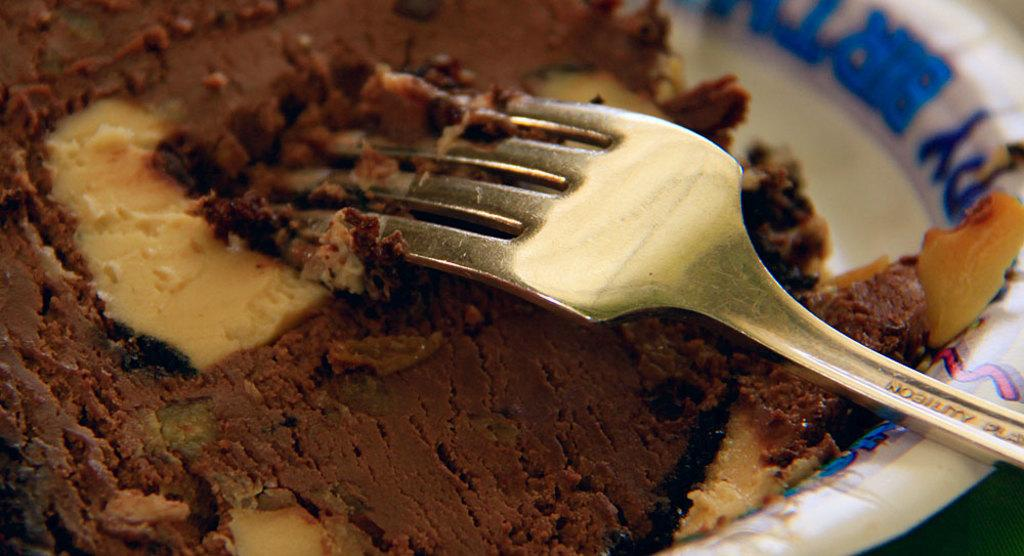What utensil is visible in the image? There is a fork in the image. What is the fork used for in the image? The fork is likely used for eating the food in the plate. What is on the plate in the image? There is food in a plate in the image. What channel is the fork tuned to in the image? The fork is not a television or any device that can be tuned to a channel; it is a utensil used for eating. 